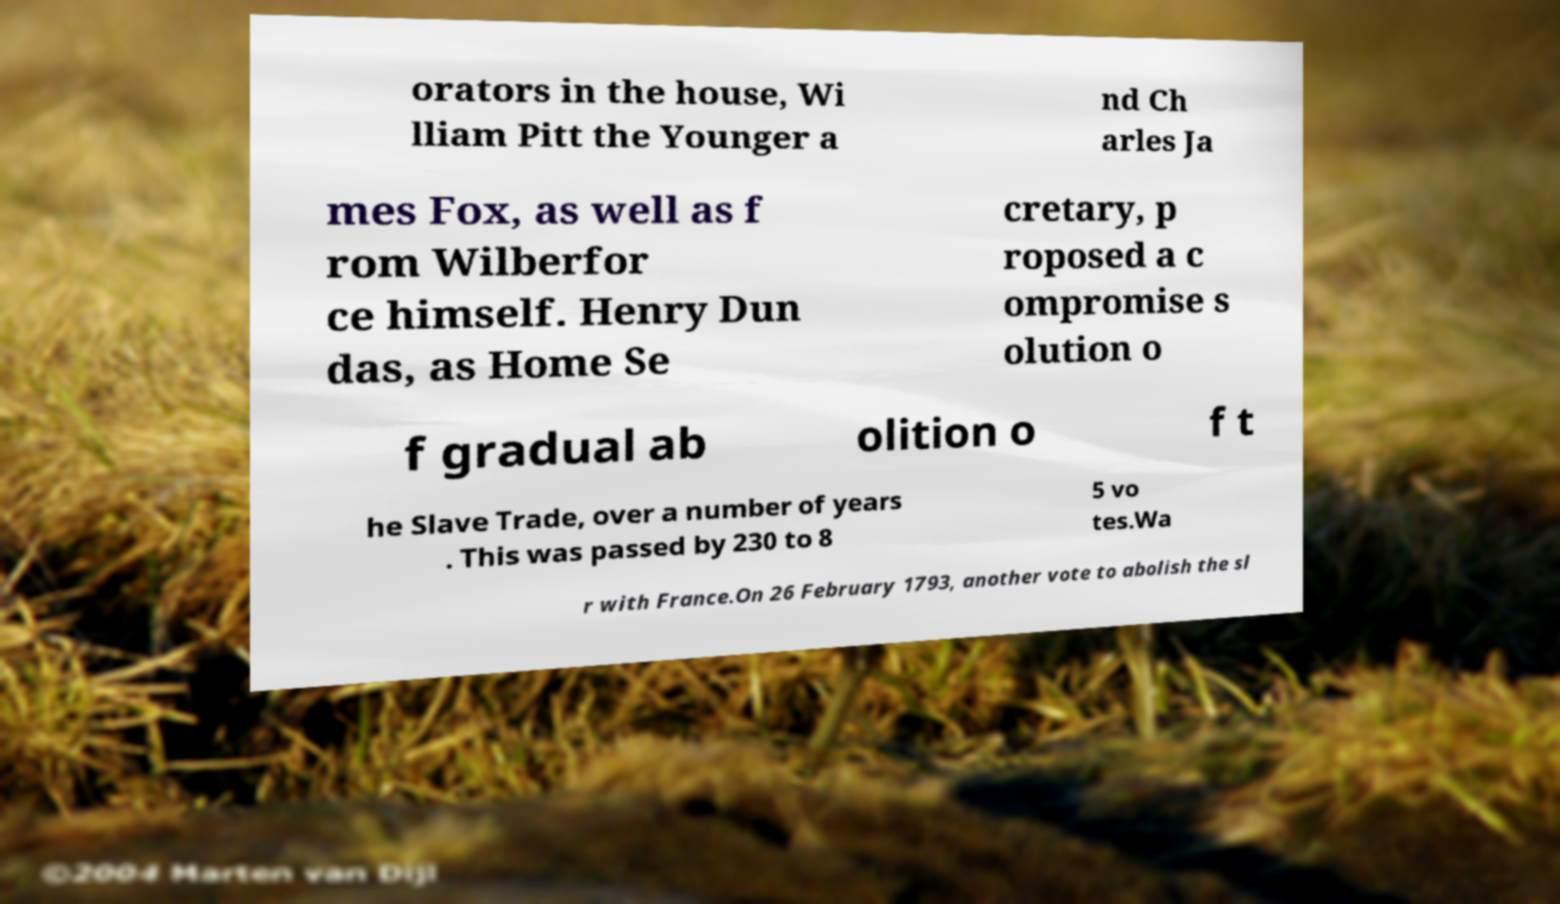Can you read and provide the text displayed in the image?This photo seems to have some interesting text. Can you extract and type it out for me? orators in the house, Wi lliam Pitt the Younger a nd Ch arles Ja mes Fox, as well as f rom Wilberfor ce himself. Henry Dun das, as Home Se cretary, p roposed a c ompromise s olution o f gradual ab olition o f t he Slave Trade, over a number of years . This was passed by 230 to 8 5 vo tes.Wa r with France.On 26 February 1793, another vote to abolish the sl 